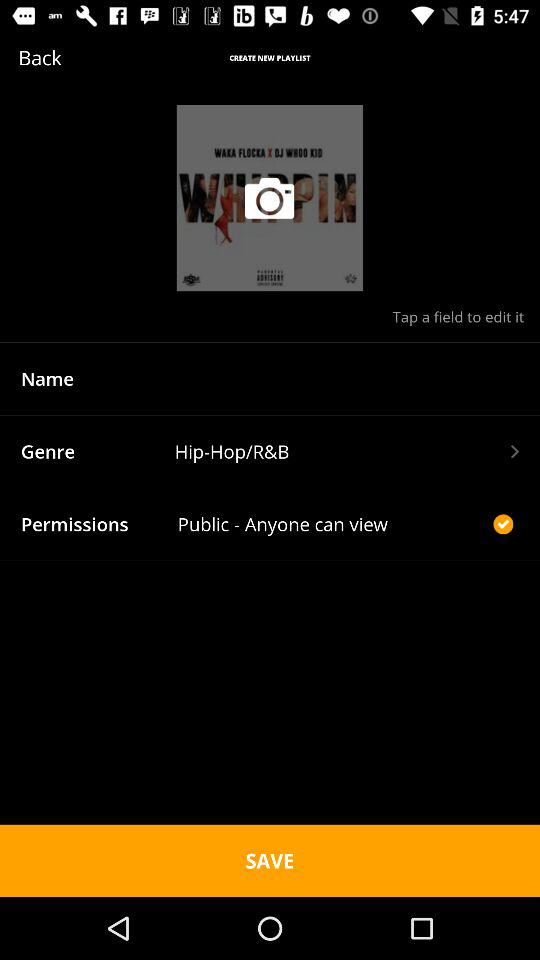What is the status of permission to the public-anyone can view?
When the provided information is insufficient, respond with <no answer>. <no answer> 